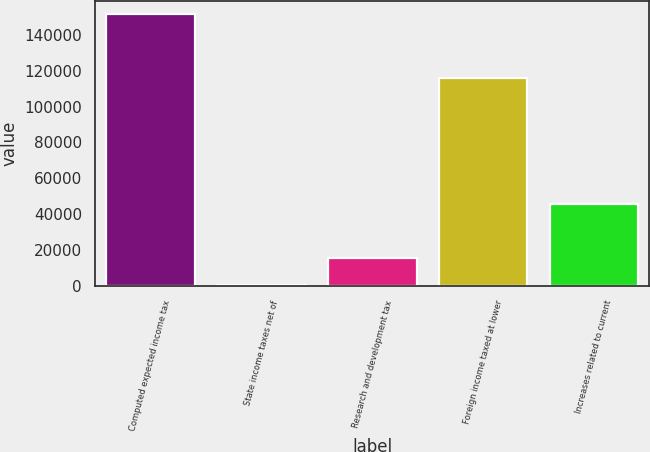Convert chart to OTSL. <chart><loc_0><loc_0><loc_500><loc_500><bar_chart><fcel>Computed expected income tax<fcel>State income taxes net of<fcel>Research and development tax<fcel>Foreign income taxed at lower<fcel>Increases related to current<nl><fcel>151324<fcel>686<fcel>15749.8<fcel>116003<fcel>45877.4<nl></chart> 